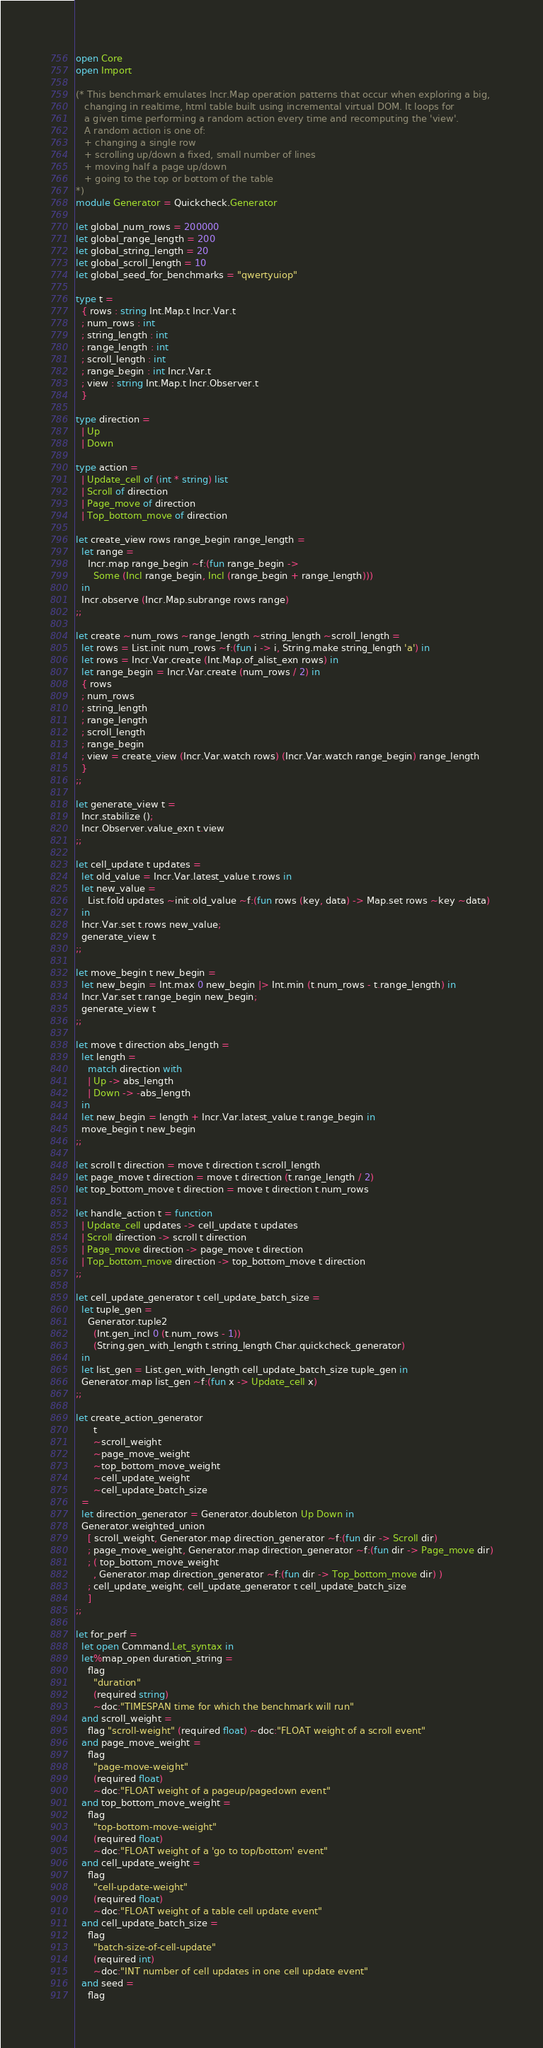Convert code to text. <code><loc_0><loc_0><loc_500><loc_500><_OCaml_>open Core
open Import

(* This benchmark emulates Incr.Map operation patterns that occur when exploring a big,
   changing in realtime, html table built using incremental virtual DOM. It loops for
   a given time performing a random action every time and recomputing the 'view'.
   A random action is one of:
   + changing a single row
   + scrolling up/down a fixed, small number of lines
   + moving half a page up/down
   + going to the top or bottom of the table
*)
module Generator = Quickcheck.Generator

let global_num_rows = 200000
let global_range_length = 200
let global_string_length = 20
let global_scroll_length = 10
let global_seed_for_benchmarks = "qwertyuiop"

type t =
  { rows : string Int.Map.t Incr.Var.t
  ; num_rows : int
  ; string_length : int
  ; range_length : int
  ; scroll_length : int
  ; range_begin : int Incr.Var.t
  ; view : string Int.Map.t Incr.Observer.t
  }

type direction =
  | Up
  | Down

type action =
  | Update_cell of (int * string) list
  | Scroll of direction
  | Page_move of direction
  | Top_bottom_move of direction

let create_view rows range_begin range_length =
  let range =
    Incr.map range_begin ~f:(fun range_begin ->
      Some (Incl range_begin, Incl (range_begin + range_length)))
  in
  Incr.observe (Incr.Map.subrange rows range)
;;

let create ~num_rows ~range_length ~string_length ~scroll_length =
  let rows = List.init num_rows ~f:(fun i -> i, String.make string_length 'a') in
  let rows = Incr.Var.create (Int.Map.of_alist_exn rows) in
  let range_begin = Incr.Var.create (num_rows / 2) in
  { rows
  ; num_rows
  ; string_length
  ; range_length
  ; scroll_length
  ; range_begin
  ; view = create_view (Incr.Var.watch rows) (Incr.Var.watch range_begin) range_length
  }
;;

let generate_view t =
  Incr.stabilize ();
  Incr.Observer.value_exn t.view
;;

let cell_update t updates =
  let old_value = Incr.Var.latest_value t.rows in
  let new_value =
    List.fold updates ~init:old_value ~f:(fun rows (key, data) -> Map.set rows ~key ~data)
  in
  Incr.Var.set t.rows new_value;
  generate_view t
;;

let move_begin t new_begin =
  let new_begin = Int.max 0 new_begin |> Int.min (t.num_rows - t.range_length) in
  Incr.Var.set t.range_begin new_begin;
  generate_view t
;;

let move t direction abs_length =
  let length =
    match direction with
    | Up -> abs_length
    | Down -> -abs_length
  in
  let new_begin = length + Incr.Var.latest_value t.range_begin in
  move_begin t new_begin
;;

let scroll t direction = move t direction t.scroll_length
let page_move t direction = move t direction (t.range_length / 2)
let top_bottom_move t direction = move t direction t.num_rows

let handle_action t = function
  | Update_cell updates -> cell_update t updates
  | Scroll direction -> scroll t direction
  | Page_move direction -> page_move t direction
  | Top_bottom_move direction -> top_bottom_move t direction
;;

let cell_update_generator t cell_update_batch_size =
  let tuple_gen =
    Generator.tuple2
      (Int.gen_incl 0 (t.num_rows - 1))
      (String.gen_with_length t.string_length Char.quickcheck_generator)
  in
  let list_gen = List.gen_with_length cell_update_batch_size tuple_gen in
  Generator.map list_gen ~f:(fun x -> Update_cell x)
;;

let create_action_generator
      t
      ~scroll_weight
      ~page_move_weight
      ~top_bottom_move_weight
      ~cell_update_weight
      ~cell_update_batch_size
  =
  let direction_generator = Generator.doubleton Up Down in
  Generator.weighted_union
    [ scroll_weight, Generator.map direction_generator ~f:(fun dir -> Scroll dir)
    ; page_move_weight, Generator.map direction_generator ~f:(fun dir -> Page_move dir)
    ; ( top_bottom_move_weight
      , Generator.map direction_generator ~f:(fun dir -> Top_bottom_move dir) )
    ; cell_update_weight, cell_update_generator t cell_update_batch_size
    ]
;;

let for_perf =
  let open Command.Let_syntax in
  let%map_open duration_string =
    flag
      "duration"
      (required string)
      ~doc:"TIMESPAN time for which the benchmark will run"
  and scroll_weight =
    flag "scroll-weight" (required float) ~doc:"FLOAT weight of a scroll event"
  and page_move_weight =
    flag
      "page-move-weight"
      (required float)
      ~doc:"FLOAT weight of a pageup/pagedown event"
  and top_bottom_move_weight =
    flag
      "top-bottom-move-weight"
      (required float)
      ~doc:"FLOAT weight of a 'go to top/bottom' event"
  and cell_update_weight =
    flag
      "cell-update-weight"
      (required float)
      ~doc:"FLOAT weight of a table cell update event"
  and cell_update_batch_size =
    flag
      "batch-size-of-cell-update"
      (required int)
      ~doc:"INT number of cell updates in one cell update event"
  and seed =
    flag</code> 